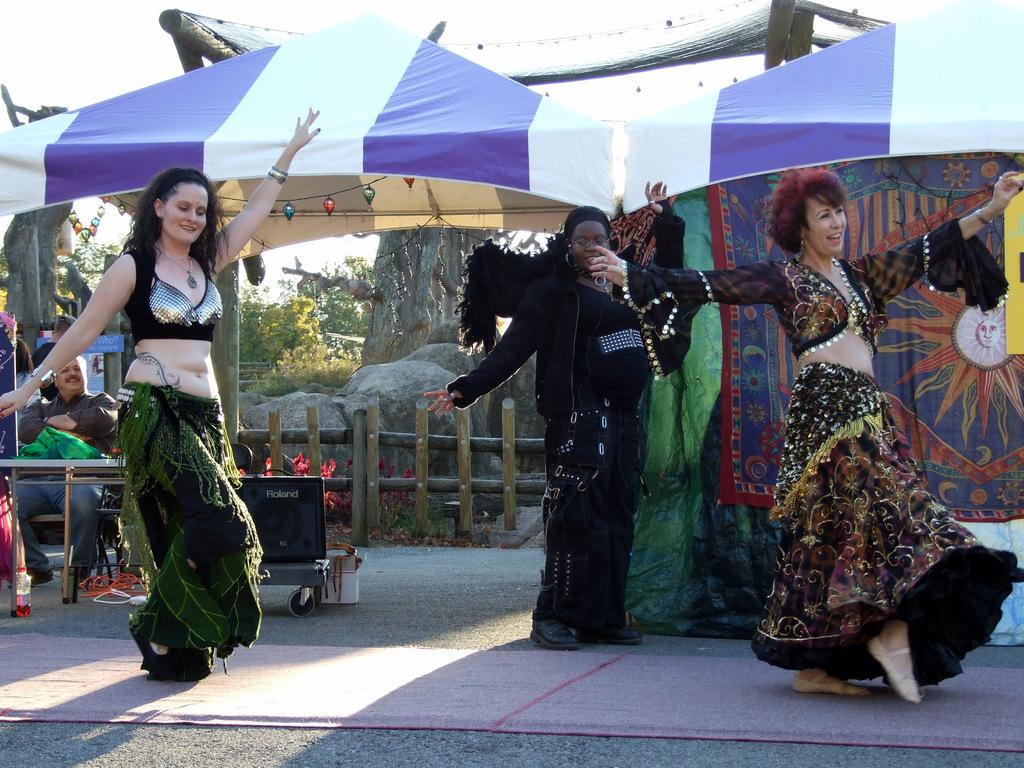What are the women in the image doing? There are three women dancing in the image. Who else is present in the image besides the women? There is a person watching the women dance. What can be seen in the background of the image? Wooden fencing, rocks, trees, and a tent are visible in the image. What type of advertisement can be seen on the tent in the image? There is no advertisement present on the tent in the image. What is the facial expression of the person watching the women dance? The provided facts do not mention the facial expression of the person watching the women dance. 